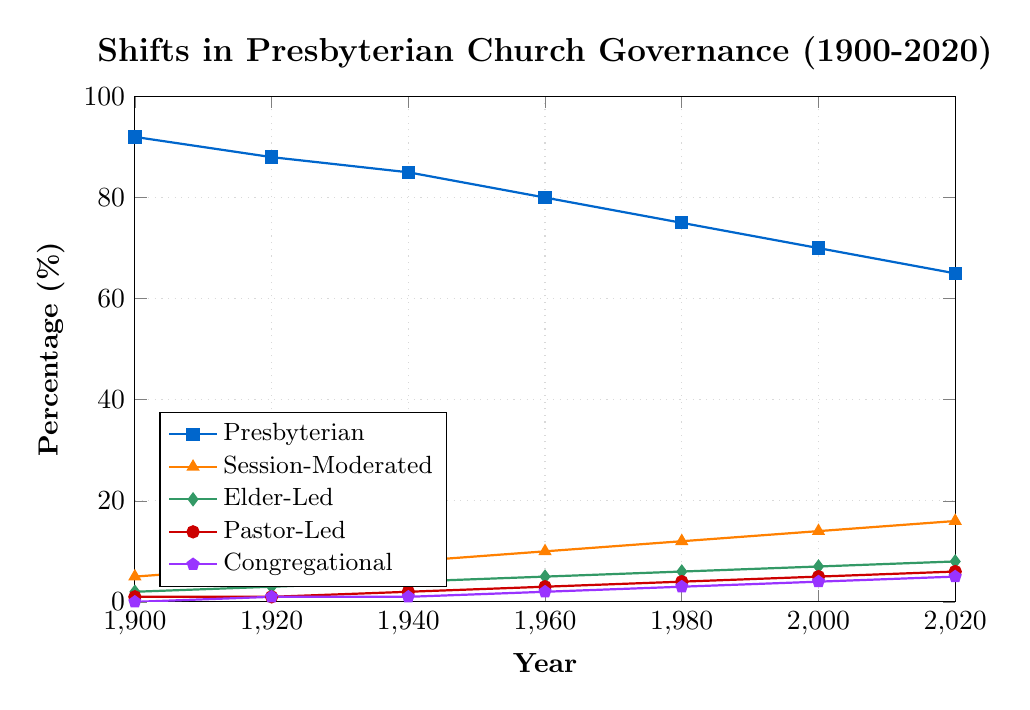What governance style had the highest percentage in 2020? By observing the chart, the highest line in 2020 is the one representing Presbyterian governance.
Answer: Presbyterian How did the percentage of Session-Moderated churches change between 1900 and 2020? From the visual trend, the percentage started at 5% in 1900 and increased to 16% in 2020. The change is 16 - 5.
Answer: 11% Which governance style showed the slowest growth from 1900 to 2020? By comparing the slopes of the lines, the Congregational style had the slowest growth, starting from 0% in 1900 and reaching only 5% by 2020.
Answer: Congregational In what year did Elder-Led churches reach 5%? Following the Elder-Led line, it intersects the 5% mark in the year 1960.
Answer: 1960 Calculate the sum of the percentages of all governance styles in 2000. Referring to the chart, the percentages in 2000 are Presbyterian (70%), Session-Moderated (14%), Elder-Led (7%), Pastor-Led (5%), and Congregational (4%). Summing these gives 70 + 14 + 7 + 5 + 4.
Answer: 100% Compare the percentage decrease of Presbyterian churches from 1900 to 2020. The percentage for Presbyterian churches in 1900 was 92%, and in 2020 it was 65%. The decrease is 92 - 65.
Answer: 27% Which governance styles had a percentage of 1% in 1920? By looking at the 1920 marker, both the Pastor-Led and Congregational styles intersect this line.
Answer: Pastor-Led and Congregational What is the visual difference in the thickness of the Elder-Led and Pastor-Led lines? Both the Elder-Led and Pastor-Led lines appear to be of equal thickness, as specified by the visual style of the chart.
Answer: Equal Which church governance increased every decade without decreasing at any point? Observing the chart, the lines for Session-Moderated, Elder-Led, Pastor-Led, and Congregational all show consistent growth without any decrease.
Answer: Session-Moderated, Elder-Led, Pastor-Led, Congregational Calculate the average increase per decade for Congregational governance from 1900 to 2020. The increase from 0% in 1900 to 5% in 2020 is 5%. Over 12 decades (2020-1900)/10, the average increase is 5/12.
Answer: 0.42% 